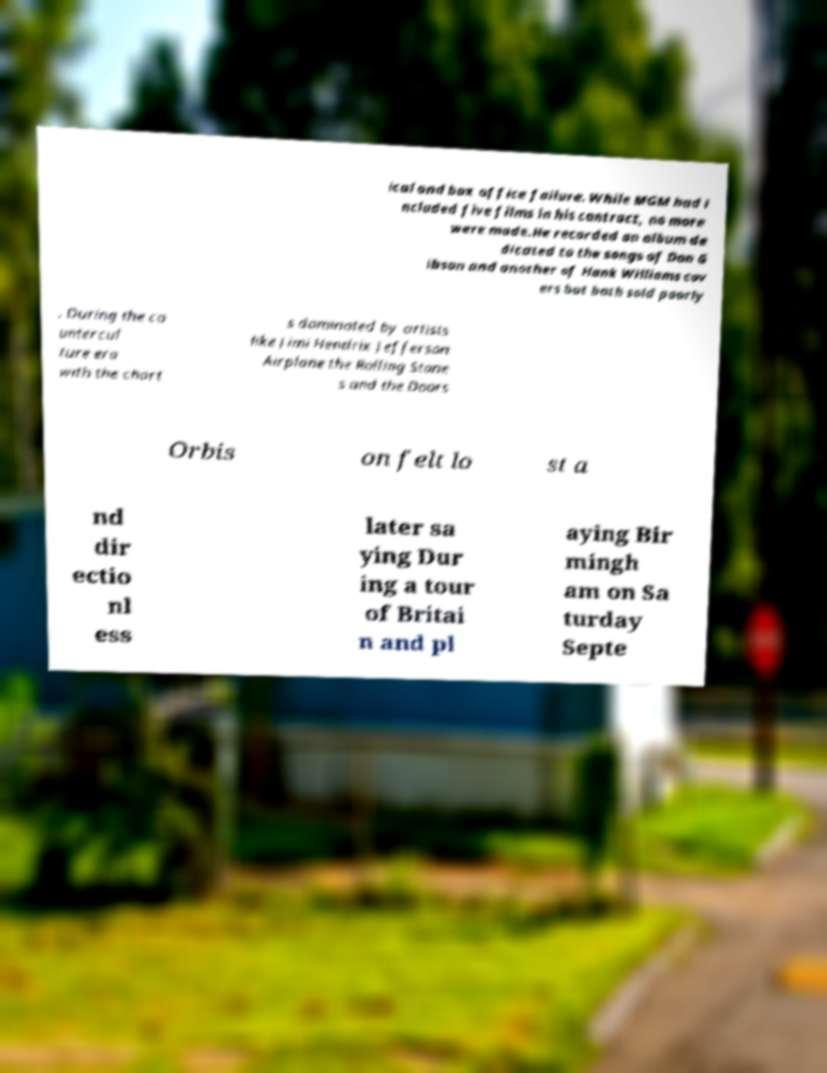Can you read and provide the text displayed in the image?This photo seems to have some interesting text. Can you extract and type it out for me? ical and box office failure. While MGM had i ncluded five films in his contract, no more were made.He recorded an album de dicated to the songs of Don G ibson and another of Hank Williams cov ers but both sold poorly . During the co untercul ture era with the chart s dominated by artists like Jimi Hendrix Jefferson Airplane the Rolling Stone s and the Doors Orbis on felt lo st a nd dir ectio nl ess later sa ying Dur ing a tour of Britai n and pl aying Bir mingh am on Sa turday Septe 